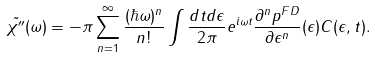Convert formula to latex. <formula><loc_0><loc_0><loc_500><loc_500>\tilde { \chi ^ { \prime \prime } } ( \omega ) = - \pi \sum _ { n = 1 } ^ { \infty } \frac { ( \hbar { \omega } ) ^ { n } } { n ! } \int \frac { d t d \epsilon } { 2 \pi } e ^ { i \omega t } \frac { \partial ^ { n } p ^ { F D } } { \partial \epsilon ^ { n } } ( \epsilon ) C ( \epsilon , t ) .</formula> 